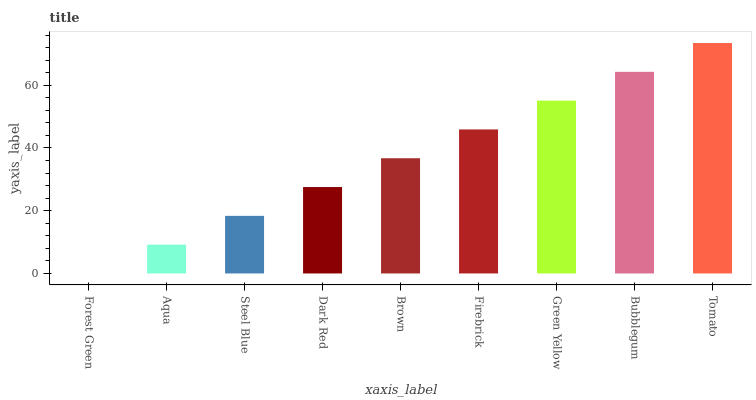Is Aqua the minimum?
Answer yes or no. No. Is Aqua the maximum?
Answer yes or no. No. Is Aqua greater than Forest Green?
Answer yes or no. Yes. Is Forest Green less than Aqua?
Answer yes or no. Yes. Is Forest Green greater than Aqua?
Answer yes or no. No. Is Aqua less than Forest Green?
Answer yes or no. No. Is Brown the high median?
Answer yes or no. Yes. Is Brown the low median?
Answer yes or no. Yes. Is Steel Blue the high median?
Answer yes or no. No. Is Bubblegum the low median?
Answer yes or no. No. 